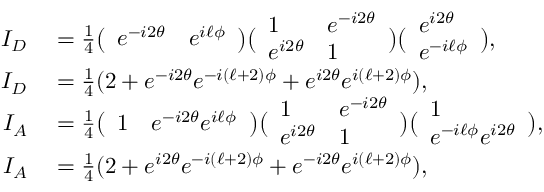Convert formula to latex. <formula><loc_0><loc_0><loc_500><loc_500>\begin{array} { r l } { I _ { D } } & = \frac { 1 } { 4 } \left ( \begin{array} { l l } { e ^ { - i 2 \theta } } & { e ^ { i \ell \phi } } \end{array} \right ) \left ( \begin{array} { l l } { 1 } & { e ^ { - i 2 \theta } } \\ { e ^ { i 2 \theta } } & { 1 } \end{array} \right ) \left ( \begin{array} { l } { e ^ { i 2 \theta } } \\ { e ^ { - i \ell \phi } } \end{array} \right ) , } \\ { I _ { D } } & = \frac { 1 } { 4 } ( 2 + e ^ { - i 2 \theta } e ^ { - i ( \ell + 2 ) \phi } + e ^ { i 2 \theta } e ^ { i ( \ell + 2 ) \phi } ) , } \\ { I _ { A } } & = \frac { 1 } { 4 } \left ( \begin{array} { l l } { 1 } & { e ^ { - i 2 \theta } e ^ { i \ell \phi } } \end{array} \right ) \left ( \begin{array} { l l } { 1 } & { e ^ { - i 2 \theta } } \\ { e ^ { i 2 \theta } } & { 1 } \end{array} \right ) \left ( \begin{array} { l } { 1 } \\ { e ^ { - i \ell \phi } e ^ { i 2 \theta } } \end{array} \right ) , } \\ { I _ { A } } & = \frac { 1 } { 4 } ( 2 + e ^ { i 2 \theta } e ^ { - i ( \ell + 2 ) \phi } + e ^ { - i 2 \theta } e ^ { i ( \ell + 2 ) \phi } ) , } \end{array}</formula> 